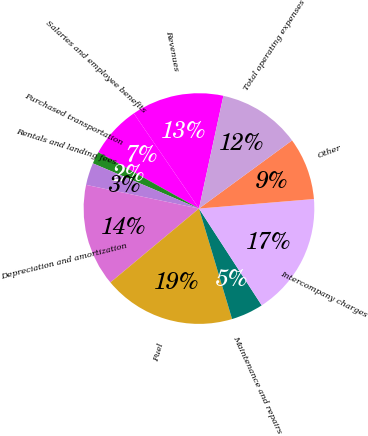Convert chart. <chart><loc_0><loc_0><loc_500><loc_500><pie_chart><fcel>Revenues<fcel>Salaries and employee benefits<fcel>Purchased transportation<fcel>Rentals and landing fees<fcel>Depreciation and amortization<fcel>Fuel<fcel>Maintenance and repairs<fcel>Intercompany charges<fcel>Other<fcel>Total operating expenses<nl><fcel>12.95%<fcel>7.33%<fcel>1.71%<fcel>3.12%<fcel>14.36%<fcel>18.57%<fcel>4.52%<fcel>17.17%<fcel>8.74%<fcel>11.55%<nl></chart> 